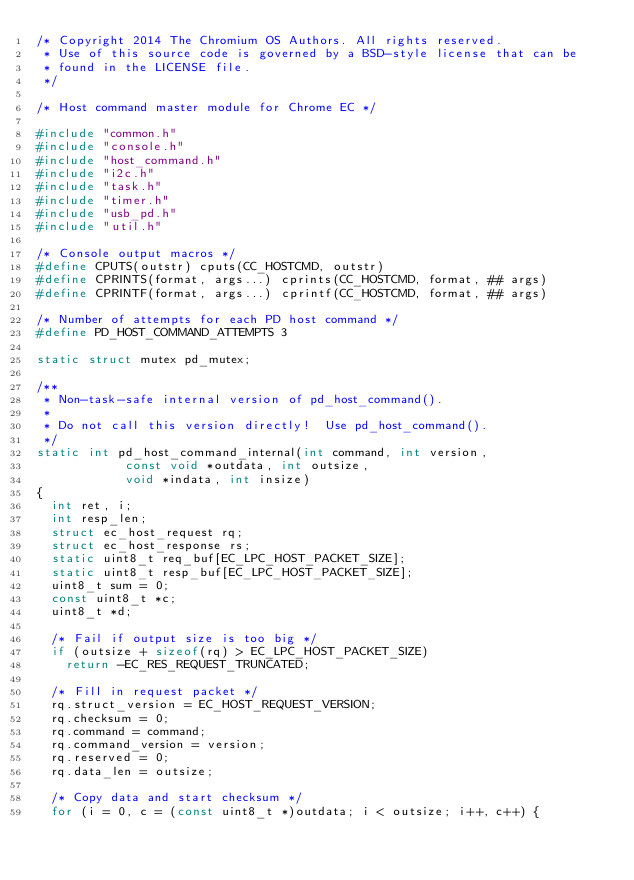Convert code to text. <code><loc_0><loc_0><loc_500><loc_500><_C_>/* Copyright 2014 The Chromium OS Authors. All rights reserved.
 * Use of this source code is governed by a BSD-style license that can be
 * found in the LICENSE file.
 */

/* Host command master module for Chrome EC */

#include "common.h"
#include "console.h"
#include "host_command.h"
#include "i2c.h"
#include "task.h"
#include "timer.h"
#include "usb_pd.h"
#include "util.h"

/* Console output macros */
#define CPUTS(outstr) cputs(CC_HOSTCMD, outstr)
#define CPRINTS(format, args...) cprints(CC_HOSTCMD, format, ## args)
#define CPRINTF(format, args...) cprintf(CC_HOSTCMD, format, ## args)

/* Number of attempts for each PD host command */
#define PD_HOST_COMMAND_ATTEMPTS 3

static struct mutex pd_mutex;

/**
 * Non-task-safe internal version of pd_host_command().
 *
 * Do not call this version directly!  Use pd_host_command().
 */
static int pd_host_command_internal(int command, int version,
				    const void *outdata, int outsize,
				    void *indata, int insize)
{
	int ret, i;
	int resp_len;
	struct ec_host_request rq;
	struct ec_host_response rs;
	static uint8_t req_buf[EC_LPC_HOST_PACKET_SIZE];
	static uint8_t resp_buf[EC_LPC_HOST_PACKET_SIZE];
	uint8_t sum = 0;
	const uint8_t *c;
	uint8_t *d;

	/* Fail if output size is too big */
	if (outsize + sizeof(rq) > EC_LPC_HOST_PACKET_SIZE)
		return -EC_RES_REQUEST_TRUNCATED;

	/* Fill in request packet */
	rq.struct_version = EC_HOST_REQUEST_VERSION;
	rq.checksum = 0;
	rq.command = command;
	rq.command_version = version;
	rq.reserved = 0;
	rq.data_len = outsize;

	/* Copy data and start checksum */
	for (i = 0, c = (const uint8_t *)outdata; i < outsize; i++, c++) {</code> 